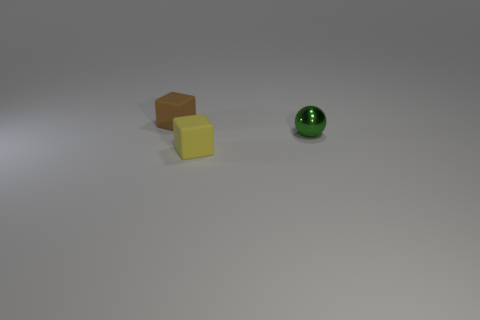What number of brown things are either tiny blocks or large things?
Offer a terse response. 1. Is there another sphere of the same color as the small metal ball?
Ensure brevity in your answer.  No. What number of cylinders are either tiny red matte things or green shiny things?
Offer a very short reply. 0. Are there more brown matte cubes than tiny green metal cylinders?
Offer a terse response. Yes. How many cyan matte cubes are the same size as the brown thing?
Make the answer very short. 0. How many things are small blocks in front of the metallic ball or cyan rubber cubes?
Your answer should be compact. 1. Are there fewer spheres than tiny purple metal objects?
Offer a terse response. No. What shape is the yellow object that is made of the same material as the small brown cube?
Keep it short and to the point. Cube. There is a green ball; are there any spheres in front of it?
Provide a short and direct response. No. Are there fewer green shiny spheres that are in front of the tiny green ball than large yellow shiny cylinders?
Make the answer very short. No. 